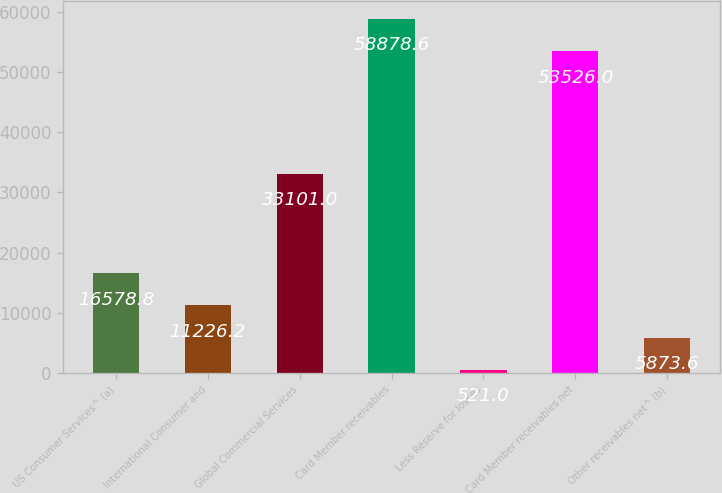Convert chart to OTSL. <chart><loc_0><loc_0><loc_500><loc_500><bar_chart><fcel>US Consumer Services^ (a)<fcel>International Consumer and<fcel>Global Commercial Services<fcel>Card Member receivables<fcel>Less Reserve for losses<fcel>Card Member receivables net<fcel>Other receivables net^ (b)<nl><fcel>16578.8<fcel>11226.2<fcel>33101<fcel>58878.6<fcel>521<fcel>53526<fcel>5873.6<nl></chart> 